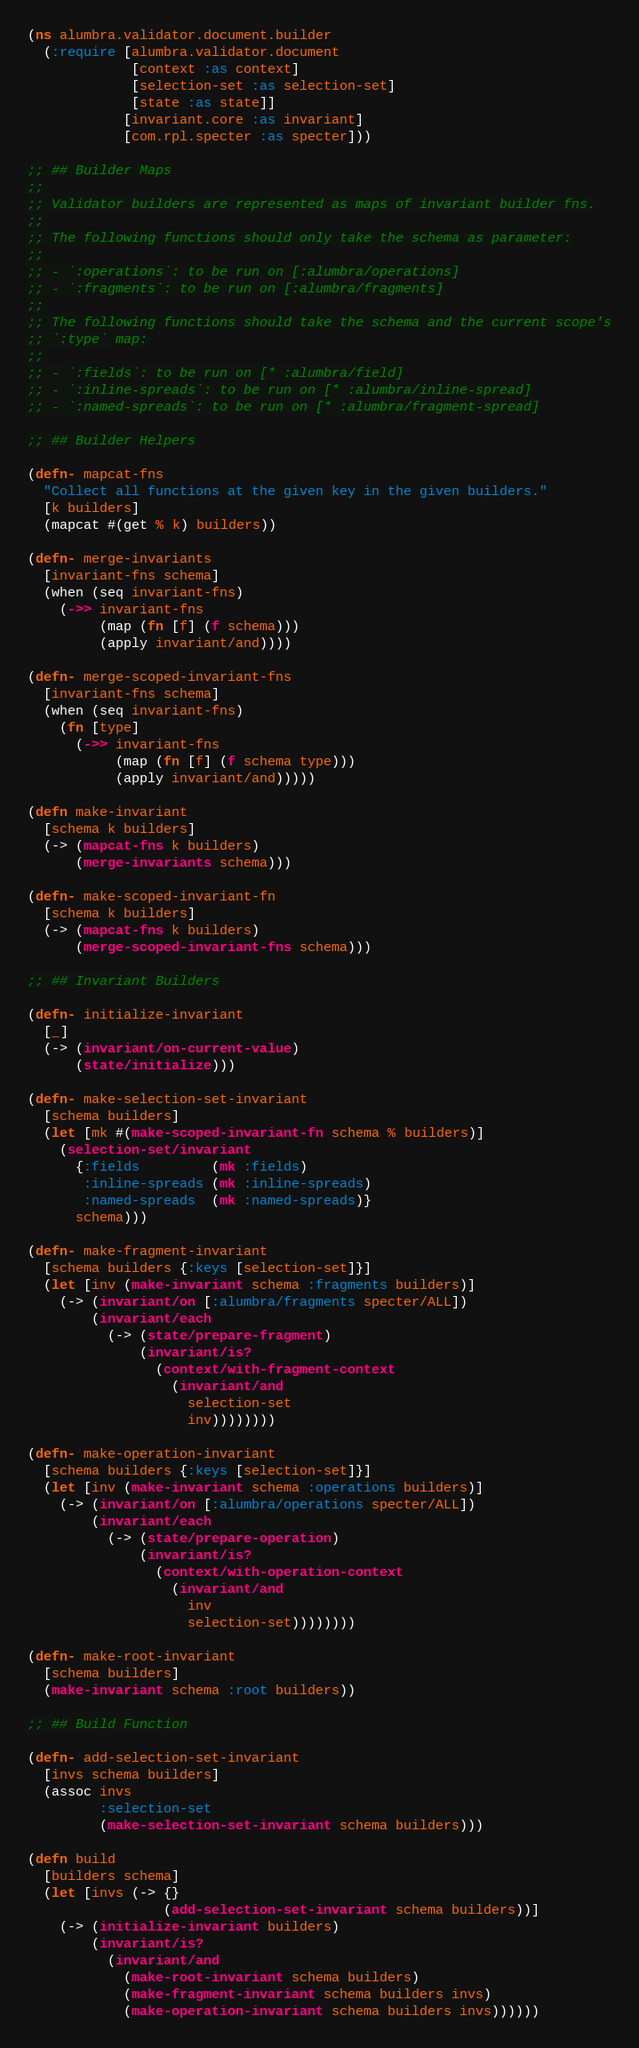<code> <loc_0><loc_0><loc_500><loc_500><_Clojure_>(ns alumbra.validator.document.builder
  (:require [alumbra.validator.document
             [context :as context]
             [selection-set :as selection-set]
             [state :as state]]
            [invariant.core :as invariant]
            [com.rpl.specter :as specter]))

;; ## Builder Maps
;;
;; Validator builders are represented as maps of invariant builder fns.
;;
;; The following functions should only take the schema as parameter:
;;
;; - `:operations`: to be run on [:alumbra/operations]
;; - `:fragments`: to be run on [:alumbra/fragments]
;;
;; The following functions should take the schema and the current scope's
;; `:type` map:
;;
;; - `:fields`: to be run on [* :alumbra/field]
;; - `:inline-spreads`: to be run on [* :alumbra/inline-spread]
;; - `:named-spreads`: to be run on [* :alumbra/fragment-spread]

;; ## Builder Helpers

(defn- mapcat-fns
  "Collect all functions at the given key in the given builders."
  [k builders]
  (mapcat #(get % k) builders))

(defn- merge-invariants
  [invariant-fns schema]
  (when (seq invariant-fns)
    (->> invariant-fns
         (map (fn [f] (f schema)))
         (apply invariant/and))))

(defn- merge-scoped-invariant-fns
  [invariant-fns schema]
  (when (seq invariant-fns)
    (fn [type]
      (->> invariant-fns
           (map (fn [f] (f schema type)))
           (apply invariant/and)))))

(defn make-invariant
  [schema k builders]
  (-> (mapcat-fns k builders)
      (merge-invariants schema)))

(defn- make-scoped-invariant-fn
  [schema k builders]
  (-> (mapcat-fns k builders)
      (merge-scoped-invariant-fns schema)))

;; ## Invariant Builders

(defn- initialize-invariant
  [_]
  (-> (invariant/on-current-value)
      (state/initialize)))

(defn- make-selection-set-invariant
  [schema builders]
  (let [mk #(make-scoped-invariant-fn schema % builders)]
    (selection-set/invariant
      {:fields         (mk :fields)
       :inline-spreads (mk :inline-spreads)
       :named-spreads  (mk :named-spreads)}
      schema)))

(defn- make-fragment-invariant
  [schema builders {:keys [selection-set]}]
  (let [inv (make-invariant schema :fragments builders)]
    (-> (invariant/on [:alumbra/fragments specter/ALL])
        (invariant/each
          (-> (state/prepare-fragment)
              (invariant/is?
                (context/with-fragment-context
                  (invariant/and
                    selection-set
                    inv))))))))

(defn- make-operation-invariant
  [schema builders {:keys [selection-set]}]
  (let [inv (make-invariant schema :operations builders)]
    (-> (invariant/on [:alumbra/operations specter/ALL])
        (invariant/each
          (-> (state/prepare-operation)
              (invariant/is?
                (context/with-operation-context
                  (invariant/and
                    inv
                    selection-set))))))))

(defn- make-root-invariant
  [schema builders]
  (make-invariant schema :root builders))

;; ## Build Function

(defn- add-selection-set-invariant
  [invs schema builders]
  (assoc invs
         :selection-set
         (make-selection-set-invariant schema builders)))

(defn build
  [builders schema]
  (let [invs (-> {}
                 (add-selection-set-invariant schema builders))]
    (-> (initialize-invariant builders)
        (invariant/is?
          (invariant/and
            (make-root-invariant schema builders)
            (make-fragment-invariant schema builders invs)
            (make-operation-invariant schema builders invs))))))
</code> 